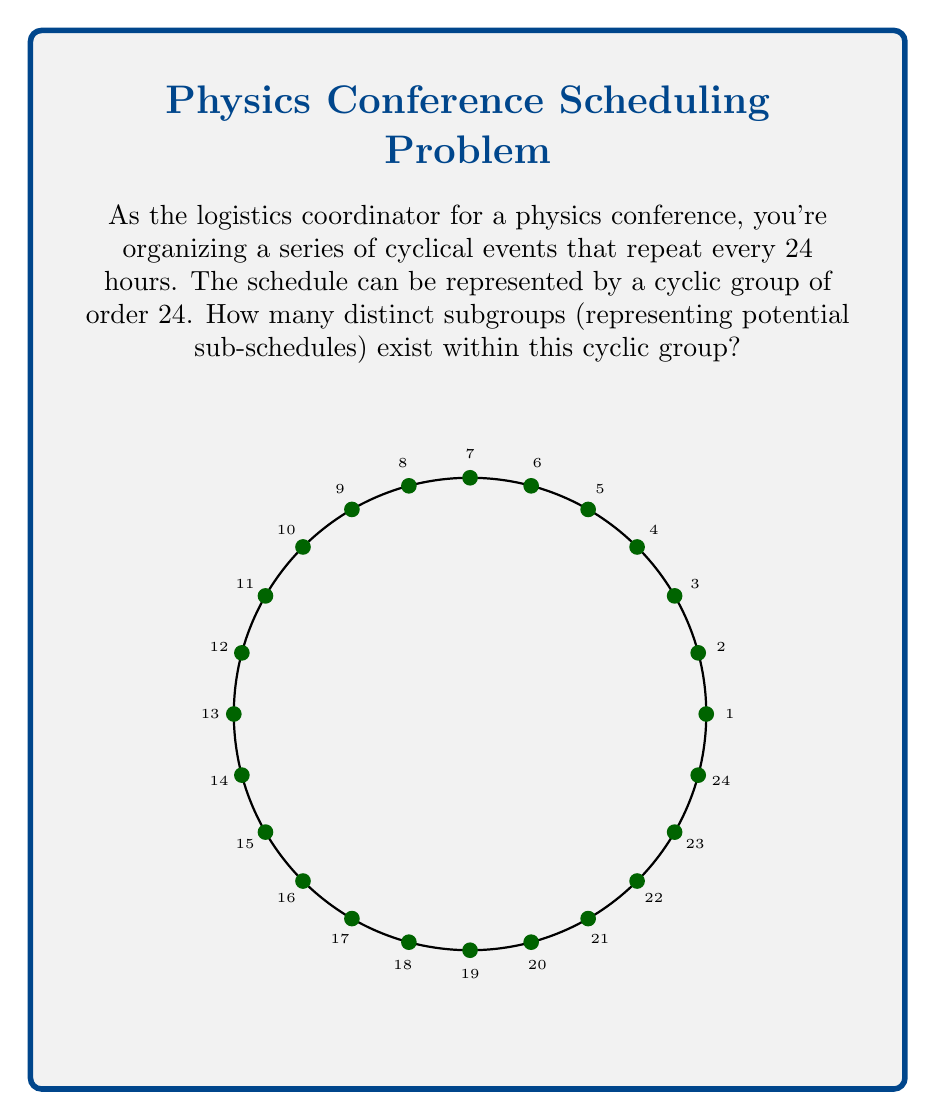Show me your answer to this math problem. To solve this problem, we need to use the properties of cyclic groups and their subgroups:

1) In a cyclic group of order n, the number of subgroups is equal to the number of divisors of n.

2) The order 24 can be factored as: $24 = 2^3 \times 3$

3) To find the number of divisors, we use the divisor function:
   For a number $n = p_1^{a_1} \times p_2^{a_2} \times ... \times p_k^{a_k}$, 
   where $p_i$ are prime factors,
   the number of divisors is given by $(a_1 + 1)(a_2 + 1)...(a_k + 1)$

4) In our case, we have:
   $24 = 2^3 \times 3^1$
   So, the number of divisors (and thus subgroups) is:
   $(3+1)(1+1) = 4 \times 2 = 8$

5) These 8 subgroups correspond to the divisors of 24:
   1, 2, 3, 4, 6, 8, 12, and 24

Each of these represents a potential sub-schedule that could be implemented within the 24-hour cycle.
Answer: 8 subgroups 